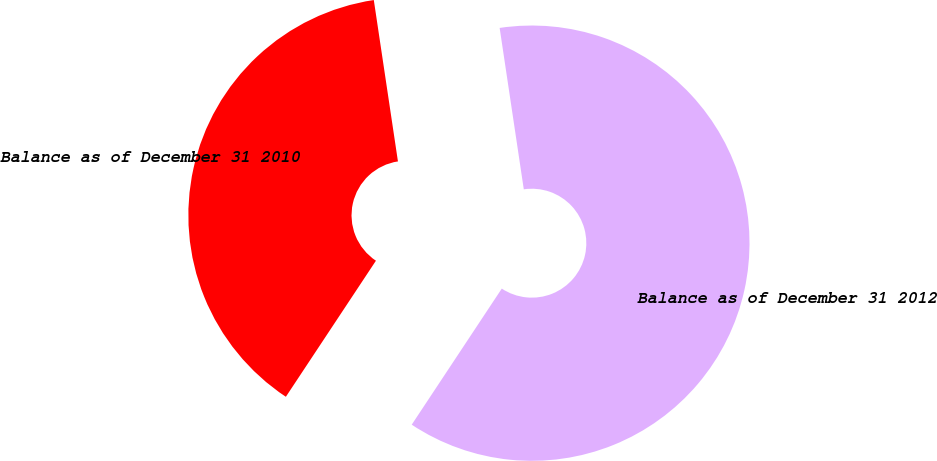<chart> <loc_0><loc_0><loc_500><loc_500><pie_chart><fcel>Balance as of December 31 2010<fcel>Balance as of December 31 2012<nl><fcel>38.33%<fcel>61.67%<nl></chart> 